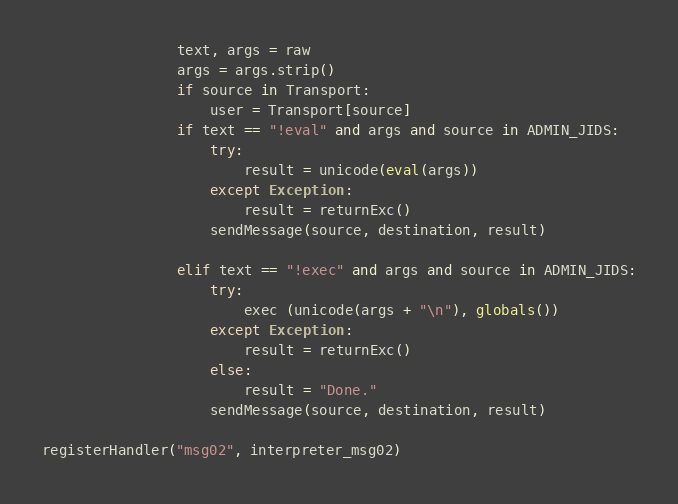<code> <loc_0><loc_0><loc_500><loc_500><_Python_>				text, args = raw
				args = args.strip()
				if source in Transport:
					user = Transport[source]
				if text == "!eval" and args and source in ADMIN_JIDS:
					try:
						result = unicode(eval(args))
					except Exception:
						result = returnExc()
					sendMessage(source, destination, result)

				elif text == "!exec" and args and source in ADMIN_JIDS:
					try:
						exec (unicode(args + "\n"), globals())
					except Exception:
						result = returnExc()
					else:
						result = "Done."
					sendMessage(source, destination, result)

registerHandler("msg02", interpreter_msg02)</code> 